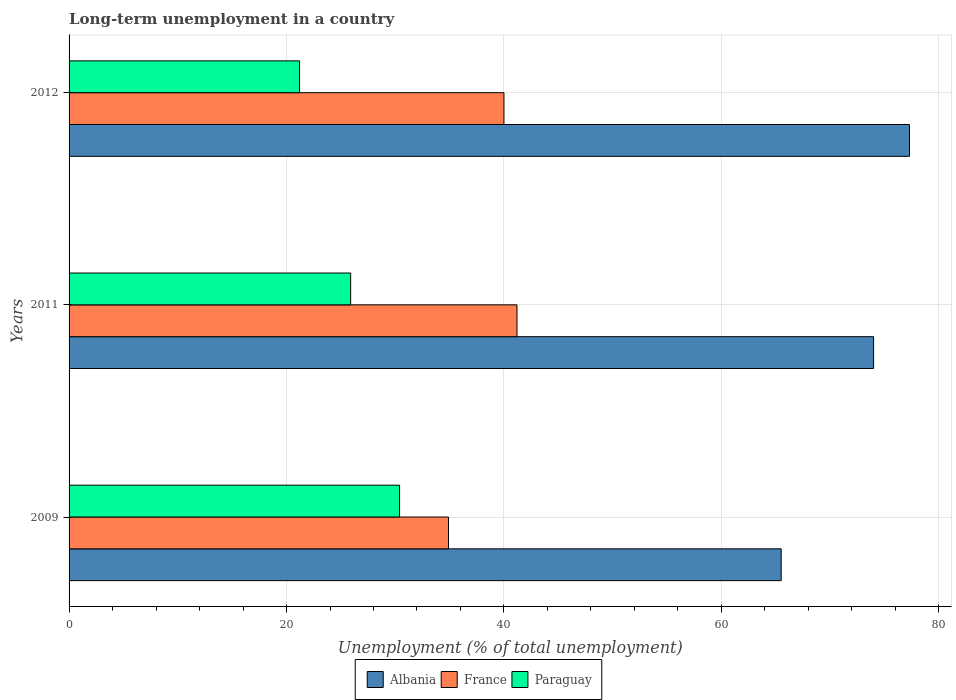Are the number of bars on each tick of the Y-axis equal?
Offer a terse response. Yes. How many bars are there on the 2nd tick from the top?
Offer a terse response. 3. How many bars are there on the 1st tick from the bottom?
Provide a short and direct response. 3. In how many cases, is the number of bars for a given year not equal to the number of legend labels?
Give a very brief answer. 0. What is the percentage of long-term unemployed population in Paraguay in 2009?
Your answer should be very brief. 30.4. Across all years, what is the maximum percentage of long-term unemployed population in Albania?
Make the answer very short. 77.3. Across all years, what is the minimum percentage of long-term unemployed population in Paraguay?
Offer a very short reply. 21.2. In which year was the percentage of long-term unemployed population in Paraguay minimum?
Provide a succinct answer. 2012. What is the total percentage of long-term unemployed population in Albania in the graph?
Make the answer very short. 216.8. What is the difference between the percentage of long-term unemployed population in Albania in 2011 and that in 2012?
Keep it short and to the point. -3.3. What is the difference between the percentage of long-term unemployed population in Albania in 2009 and the percentage of long-term unemployed population in France in 2011?
Ensure brevity in your answer.  24.3. What is the average percentage of long-term unemployed population in Paraguay per year?
Your response must be concise. 25.83. In the year 2011, what is the difference between the percentage of long-term unemployed population in Paraguay and percentage of long-term unemployed population in Albania?
Make the answer very short. -48.1. What is the ratio of the percentage of long-term unemployed population in France in 2011 to that in 2012?
Provide a succinct answer. 1.03. Is the percentage of long-term unemployed population in France in 2009 less than that in 2012?
Offer a terse response. Yes. What is the difference between the highest and the second highest percentage of long-term unemployed population in France?
Give a very brief answer. 1.2. What is the difference between the highest and the lowest percentage of long-term unemployed population in Albania?
Your answer should be compact. 11.8. Is the sum of the percentage of long-term unemployed population in Albania in 2009 and 2011 greater than the maximum percentage of long-term unemployed population in France across all years?
Your answer should be compact. Yes. What does the 2nd bar from the top in 2011 represents?
Provide a succinct answer. France. What does the 1st bar from the bottom in 2009 represents?
Give a very brief answer. Albania. What is the difference between two consecutive major ticks on the X-axis?
Keep it short and to the point. 20. Where does the legend appear in the graph?
Make the answer very short. Bottom center. How many legend labels are there?
Provide a short and direct response. 3. How are the legend labels stacked?
Offer a terse response. Horizontal. What is the title of the graph?
Ensure brevity in your answer.  Long-term unemployment in a country. What is the label or title of the X-axis?
Make the answer very short. Unemployment (% of total unemployment). What is the Unemployment (% of total unemployment) in Albania in 2009?
Ensure brevity in your answer.  65.5. What is the Unemployment (% of total unemployment) in France in 2009?
Your answer should be very brief. 34.9. What is the Unemployment (% of total unemployment) of Paraguay in 2009?
Provide a short and direct response. 30.4. What is the Unemployment (% of total unemployment) in France in 2011?
Your answer should be very brief. 41.2. What is the Unemployment (% of total unemployment) in Paraguay in 2011?
Ensure brevity in your answer.  25.9. What is the Unemployment (% of total unemployment) of Albania in 2012?
Your answer should be compact. 77.3. What is the Unemployment (% of total unemployment) in Paraguay in 2012?
Ensure brevity in your answer.  21.2. Across all years, what is the maximum Unemployment (% of total unemployment) of Albania?
Your answer should be compact. 77.3. Across all years, what is the maximum Unemployment (% of total unemployment) of France?
Provide a short and direct response. 41.2. Across all years, what is the maximum Unemployment (% of total unemployment) of Paraguay?
Your answer should be compact. 30.4. Across all years, what is the minimum Unemployment (% of total unemployment) in Albania?
Keep it short and to the point. 65.5. Across all years, what is the minimum Unemployment (% of total unemployment) in France?
Offer a very short reply. 34.9. Across all years, what is the minimum Unemployment (% of total unemployment) in Paraguay?
Keep it short and to the point. 21.2. What is the total Unemployment (% of total unemployment) of Albania in the graph?
Offer a terse response. 216.8. What is the total Unemployment (% of total unemployment) in France in the graph?
Your answer should be very brief. 116.1. What is the total Unemployment (% of total unemployment) in Paraguay in the graph?
Offer a very short reply. 77.5. What is the difference between the Unemployment (% of total unemployment) of Albania in 2009 and that in 2011?
Ensure brevity in your answer.  -8.5. What is the difference between the Unemployment (% of total unemployment) of France in 2009 and that in 2011?
Provide a succinct answer. -6.3. What is the difference between the Unemployment (% of total unemployment) in Paraguay in 2009 and that in 2011?
Ensure brevity in your answer.  4.5. What is the difference between the Unemployment (% of total unemployment) of Paraguay in 2009 and that in 2012?
Make the answer very short. 9.2. What is the difference between the Unemployment (% of total unemployment) of Albania in 2011 and that in 2012?
Provide a short and direct response. -3.3. What is the difference between the Unemployment (% of total unemployment) in France in 2011 and that in 2012?
Provide a succinct answer. 1.2. What is the difference between the Unemployment (% of total unemployment) of Paraguay in 2011 and that in 2012?
Your answer should be compact. 4.7. What is the difference between the Unemployment (% of total unemployment) of Albania in 2009 and the Unemployment (% of total unemployment) of France in 2011?
Your answer should be very brief. 24.3. What is the difference between the Unemployment (% of total unemployment) in Albania in 2009 and the Unemployment (% of total unemployment) in Paraguay in 2011?
Offer a very short reply. 39.6. What is the difference between the Unemployment (% of total unemployment) of France in 2009 and the Unemployment (% of total unemployment) of Paraguay in 2011?
Keep it short and to the point. 9. What is the difference between the Unemployment (% of total unemployment) of Albania in 2009 and the Unemployment (% of total unemployment) of France in 2012?
Ensure brevity in your answer.  25.5. What is the difference between the Unemployment (% of total unemployment) of Albania in 2009 and the Unemployment (% of total unemployment) of Paraguay in 2012?
Keep it short and to the point. 44.3. What is the difference between the Unemployment (% of total unemployment) of Albania in 2011 and the Unemployment (% of total unemployment) of France in 2012?
Provide a succinct answer. 34. What is the difference between the Unemployment (% of total unemployment) in Albania in 2011 and the Unemployment (% of total unemployment) in Paraguay in 2012?
Offer a very short reply. 52.8. What is the average Unemployment (% of total unemployment) in Albania per year?
Provide a succinct answer. 72.27. What is the average Unemployment (% of total unemployment) in France per year?
Keep it short and to the point. 38.7. What is the average Unemployment (% of total unemployment) of Paraguay per year?
Your response must be concise. 25.83. In the year 2009, what is the difference between the Unemployment (% of total unemployment) in Albania and Unemployment (% of total unemployment) in France?
Keep it short and to the point. 30.6. In the year 2009, what is the difference between the Unemployment (% of total unemployment) of Albania and Unemployment (% of total unemployment) of Paraguay?
Keep it short and to the point. 35.1. In the year 2011, what is the difference between the Unemployment (% of total unemployment) of Albania and Unemployment (% of total unemployment) of France?
Offer a terse response. 32.8. In the year 2011, what is the difference between the Unemployment (% of total unemployment) in Albania and Unemployment (% of total unemployment) in Paraguay?
Your answer should be very brief. 48.1. In the year 2012, what is the difference between the Unemployment (% of total unemployment) in Albania and Unemployment (% of total unemployment) in France?
Your answer should be very brief. 37.3. In the year 2012, what is the difference between the Unemployment (% of total unemployment) in Albania and Unemployment (% of total unemployment) in Paraguay?
Keep it short and to the point. 56.1. What is the ratio of the Unemployment (% of total unemployment) in Albania in 2009 to that in 2011?
Give a very brief answer. 0.89. What is the ratio of the Unemployment (% of total unemployment) in France in 2009 to that in 2011?
Provide a succinct answer. 0.85. What is the ratio of the Unemployment (% of total unemployment) of Paraguay in 2009 to that in 2011?
Your answer should be very brief. 1.17. What is the ratio of the Unemployment (% of total unemployment) of Albania in 2009 to that in 2012?
Keep it short and to the point. 0.85. What is the ratio of the Unemployment (% of total unemployment) in France in 2009 to that in 2012?
Your response must be concise. 0.87. What is the ratio of the Unemployment (% of total unemployment) in Paraguay in 2009 to that in 2012?
Ensure brevity in your answer.  1.43. What is the ratio of the Unemployment (% of total unemployment) in Albania in 2011 to that in 2012?
Provide a succinct answer. 0.96. What is the ratio of the Unemployment (% of total unemployment) in France in 2011 to that in 2012?
Offer a terse response. 1.03. What is the ratio of the Unemployment (% of total unemployment) of Paraguay in 2011 to that in 2012?
Provide a short and direct response. 1.22. What is the difference between the highest and the second highest Unemployment (% of total unemployment) in Paraguay?
Your answer should be compact. 4.5. What is the difference between the highest and the lowest Unemployment (% of total unemployment) in Albania?
Offer a very short reply. 11.8. 